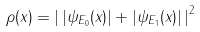Convert formula to latex. <formula><loc_0><loc_0><loc_500><loc_500>\rho ( x ) = \left | \, | \psi _ { E _ { 0 } } ( x ) | + | \psi _ { E _ { 1 } } ( x ) | \, \right | ^ { 2 }</formula> 